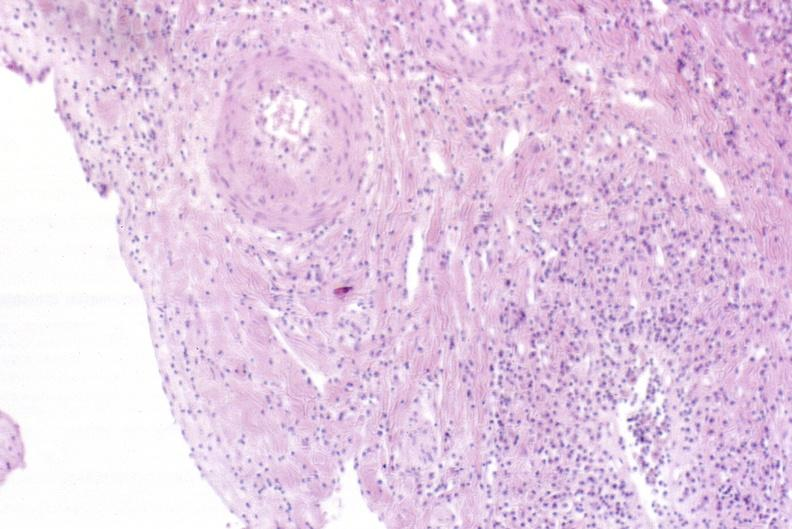s liver present?
Answer the question using a single word or phrase. Yes 